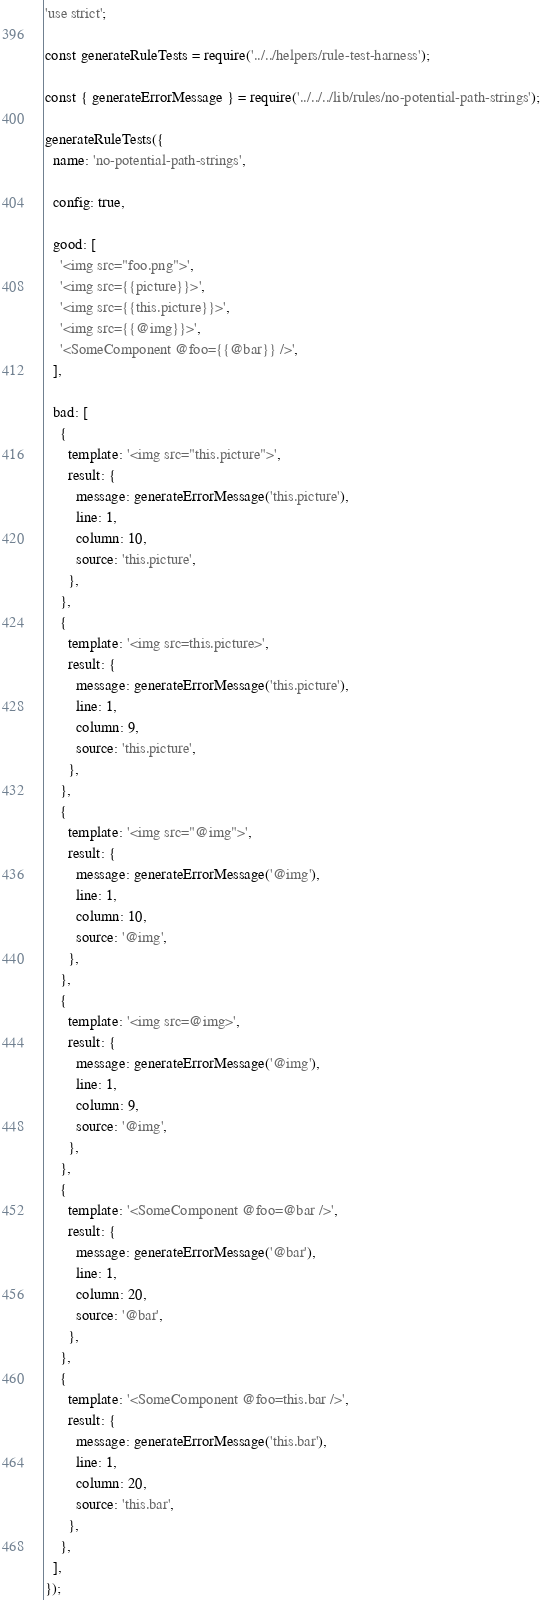Convert code to text. <code><loc_0><loc_0><loc_500><loc_500><_JavaScript_>'use strict';

const generateRuleTests = require('../../helpers/rule-test-harness');

const { generateErrorMessage } = require('../../../lib/rules/no-potential-path-strings');

generateRuleTests({
  name: 'no-potential-path-strings',

  config: true,

  good: [
    '<img src="foo.png">',
    '<img src={{picture}}>',
    '<img src={{this.picture}}>',
    '<img src={{@img}}>',
    '<SomeComponent @foo={{@bar}} />',
  ],

  bad: [
    {
      template: '<img src="this.picture">',
      result: {
        message: generateErrorMessage('this.picture'),
        line: 1,
        column: 10,
        source: 'this.picture',
      },
    },
    {
      template: '<img src=this.picture>',
      result: {
        message: generateErrorMessage('this.picture'),
        line: 1,
        column: 9,
        source: 'this.picture',
      },
    },
    {
      template: '<img src="@img">',
      result: {
        message: generateErrorMessage('@img'),
        line: 1,
        column: 10,
        source: '@img',
      },
    },
    {
      template: '<img src=@img>',
      result: {
        message: generateErrorMessage('@img'),
        line: 1,
        column: 9,
        source: '@img',
      },
    },
    {
      template: '<SomeComponent @foo=@bar />',
      result: {
        message: generateErrorMessage('@bar'),
        line: 1,
        column: 20,
        source: '@bar',
      },
    },
    {
      template: '<SomeComponent @foo=this.bar />',
      result: {
        message: generateErrorMessage('this.bar'),
        line: 1,
        column: 20,
        source: 'this.bar',
      },
    },
  ],
});
</code> 